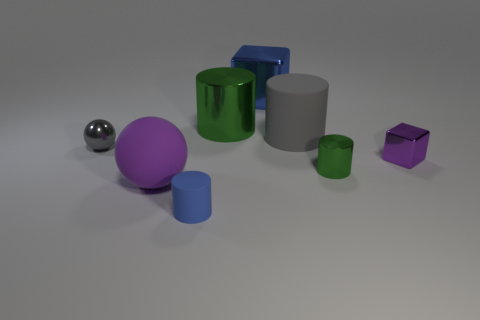There is a large thing that is the same color as the small shiny ball; what is its material?
Ensure brevity in your answer.  Rubber. What number of large things have the same color as the shiny ball?
Offer a terse response. 1. What number of things are metallic objects that are to the right of the gray sphere or cyan rubber spheres?
Give a very brief answer. 4. The large thing that is the same material as the gray cylinder is what color?
Give a very brief answer. Purple. Are there any purple metal cubes that have the same size as the blue matte thing?
Your response must be concise. Yes. What number of things are small shiny cylinders that are to the left of the tiny metal block or small shiny things in front of the tiny metallic sphere?
Offer a terse response. 2. There is a matte thing that is the same size as the gray rubber cylinder; what is its shape?
Keep it short and to the point. Sphere. Is there a gray object that has the same shape as the small green metallic object?
Offer a terse response. Yes. Is the number of big green cylinders less than the number of matte things?
Keep it short and to the point. Yes. Does the purple object that is behind the large purple object have the same size as the rubber thing that is behind the big ball?
Provide a short and direct response. No. 